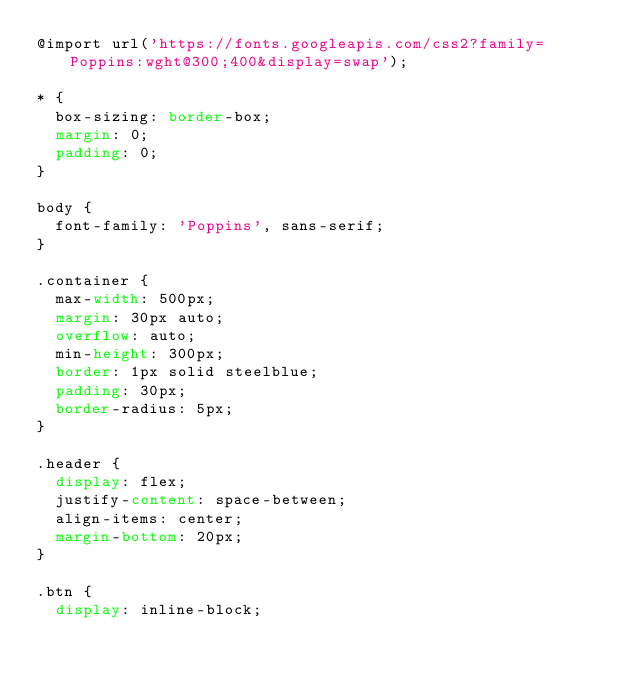<code> <loc_0><loc_0><loc_500><loc_500><_CSS_>@import url('https://fonts.googleapis.com/css2?family=Poppins:wght@300;400&display=swap');

* {
  box-sizing: border-box;
  margin: 0;
  padding: 0;
}

body {
  font-family: 'Poppins', sans-serif;
}

.container {
  max-width: 500px;
  margin: 30px auto;
  overflow: auto;
  min-height: 300px;
  border: 1px solid steelblue;
  padding: 30px;
  border-radius: 5px;
}

.header {
  display: flex;
  justify-content: space-between;
  align-items: center;
  margin-bottom: 20px;
}

.btn {
  display: inline-block;</code> 